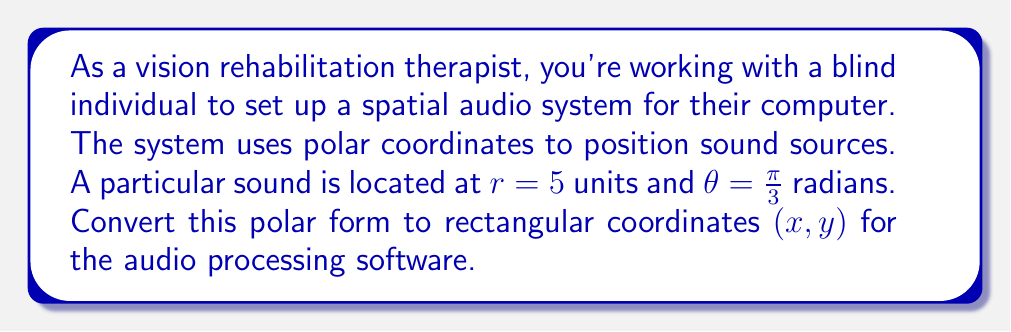Give your solution to this math problem. To convert from polar form $(r, \theta)$ to rectangular form $(x, y)$, we use the following formulas:

$$x = r \cos(\theta)$$
$$y = r \sin(\theta)$$

Given:
$r = 5$
$\theta = \frac{\pi}{3}$

Step 1: Calculate x
$$x = r \cos(\theta) = 5 \cos(\frac{\pi}{3})$$

$\cos(\frac{\pi}{3}) = \frac{1}{2}$, so:

$$x = 5 \cdot \frac{1}{2} = \frac{5}{2} = 2.5$$

Step 2: Calculate y
$$y = r \sin(\theta) = 5 \sin(\frac{\pi}{3})$$

$\sin(\frac{\pi}{3}) = \frac{\sqrt{3}}{2}$, so:

$$y = 5 \cdot \frac{\sqrt{3}}{2} = \frac{5\sqrt{3}}{2} \approx 4.33$$

Therefore, the rectangular coordinates are approximately $(2.5, 4.33)$.
Answer: $(2.5, 4.33)$ 